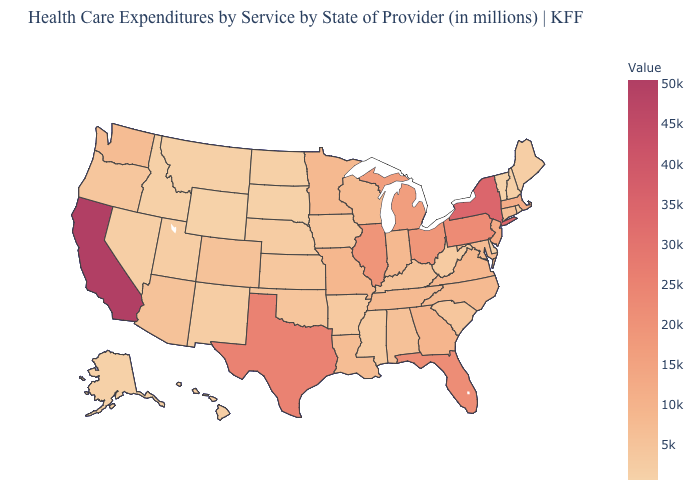Does the map have missing data?
Short answer required. No. Which states hav the highest value in the West?
Give a very brief answer. California. Does California have the highest value in the USA?
Quick response, please. Yes. Among the states that border Wyoming , does Nebraska have the highest value?
Be succinct. No. Which states have the lowest value in the USA?
Short answer required. Wyoming. 